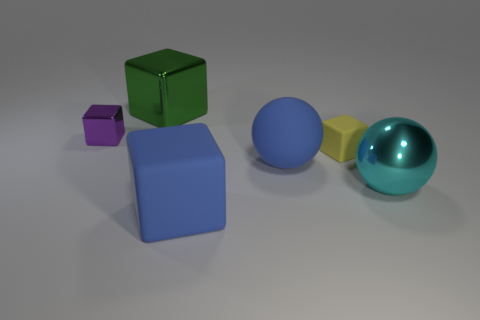Does the big rubber cube have the same color as the rubber ball?
Ensure brevity in your answer.  Yes. The shiny ball is what color?
Offer a terse response. Cyan. The large blue rubber thing that is in front of the big blue rubber object behind the matte cube in front of the tiny yellow object is what shape?
Keep it short and to the point. Cube. How many other things are the same color as the large metal block?
Make the answer very short. 0. Is the number of large blocks that are in front of the purple metallic thing greater than the number of green cubes that are in front of the large green cube?
Give a very brief answer. Yes. Are there any small cubes to the right of the big green cube?
Your answer should be compact. Yes. There is a thing that is behind the yellow object and right of the purple metallic object; what material is it made of?
Ensure brevity in your answer.  Metal. What is the color of the large metallic thing that is the same shape as the tiny yellow rubber object?
Provide a short and direct response. Green. Are there any cyan metallic things to the right of the small object left of the large matte ball?
Make the answer very short. Yes. How big is the blue sphere?
Provide a short and direct response. Large. 